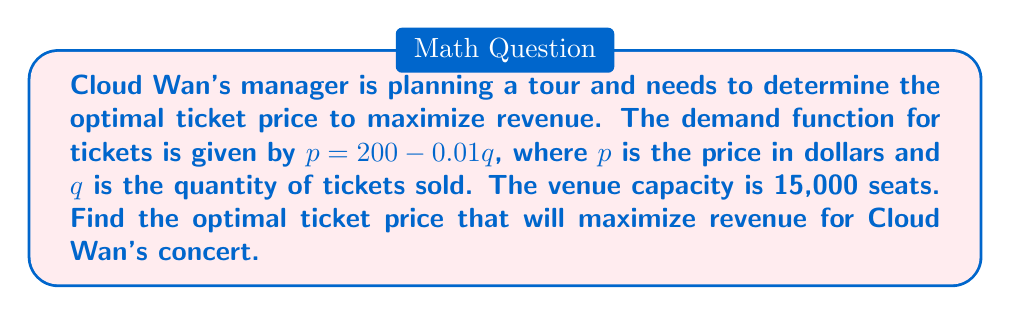Solve this math problem. 1) The revenue function $R$ is given by price times quantity: $R = pq$

2) Substitute the demand function into the revenue function:
   $R = (200 - 0.01q)q = 200q - 0.01q^2$

3) To find the maximum revenue, differentiate $R$ with respect to $q$ and set it to zero:
   $$\frac{dR}{dq} = 200 - 0.02q = 0$$

4) Solve for $q$:
   $200 - 0.02q = 0$
   $0.02q = 200$
   $q = 10,000$

5) Check the second derivative to confirm it's a maximum:
   $$\frac{d^2R}{dq^2} = -0.02 < 0$$
   This confirms it's a maximum.

6) The optimal quantity is 10,000, which is within the venue capacity of 15,000.

7) To find the optimal price, substitute $q = 10,000$ into the demand function:
   $p = 200 - 0.01(10,000) = 200 - 100 = 100$

Therefore, the optimal ticket price is $100.
Answer: $100 